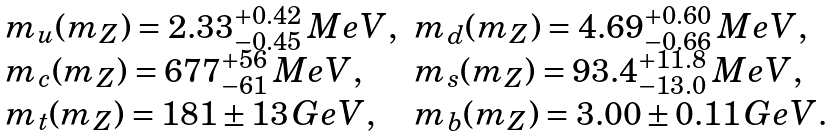<formula> <loc_0><loc_0><loc_500><loc_500>\begin{array} { l l } m _ { u } ( m _ { Z } ) = 2 . 3 3 ^ { + 0 . 4 2 } _ { - 0 . 4 5 } \, M e V , & m _ { d } ( m _ { Z } ) = 4 . 6 9 ^ { + 0 . 6 0 } _ { - 0 . 6 6 } \, M e V , \\ m _ { c } ( m _ { Z } ) = 6 7 7 ^ { + 5 6 } _ { - 6 1 } \, M e V , & m _ { s } ( m _ { Z } ) = 9 3 . 4 ^ { + 1 1 . 8 } _ { - 1 3 . 0 } \, M e V , \\ m _ { t } ( m _ { Z } ) = 1 8 1 \pm 1 3 \, G e V , & m _ { b } ( m _ { Z } ) = 3 . 0 0 \pm 0 . 1 1 \, G e V . \end{array}</formula> 